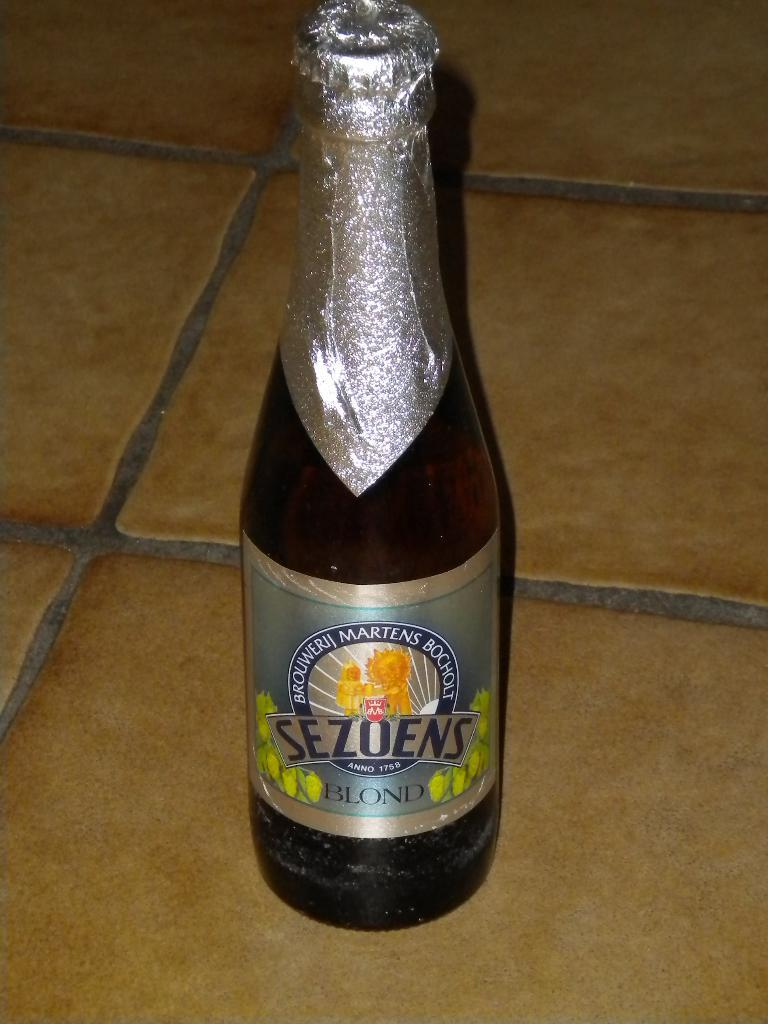Provide a one-sentence caption for the provided image. A bottle of "Sezoens Blond" is shown with a silver wrapping. 